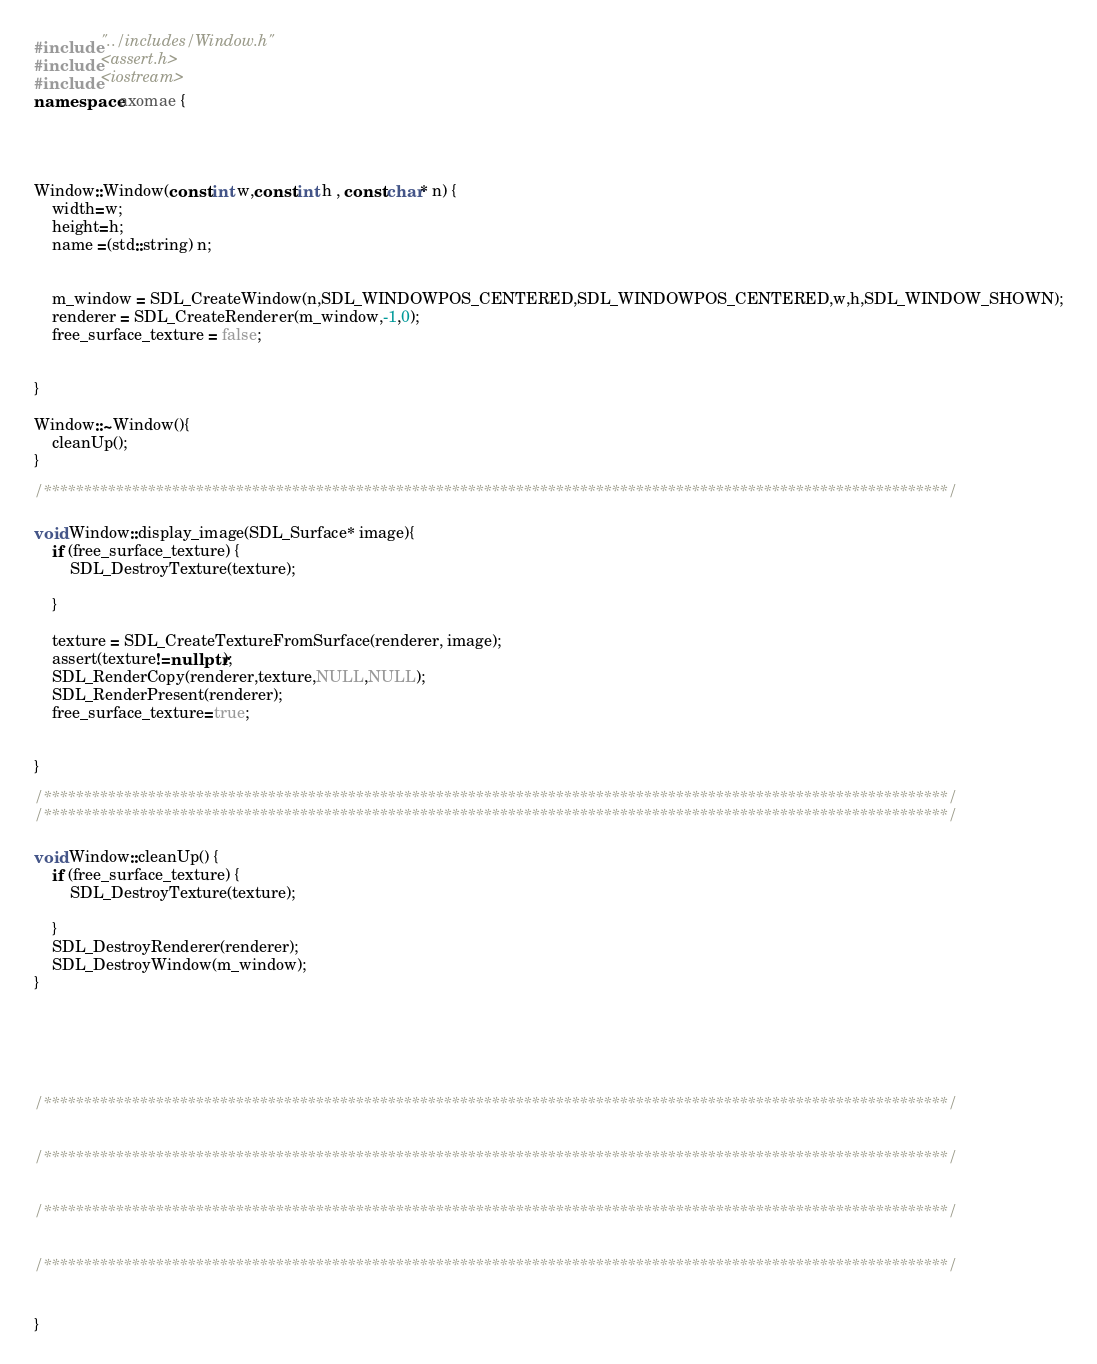Convert code to text. <code><loc_0><loc_0><loc_500><loc_500><_C++_>#include "../includes/Window.h"
#include <assert.h>
#include <iostream>
namespace axomae {




Window::Window(const int w,const int h , const char* n) {
	width=w; 
	height=h;
	name =(std::string) n;


	m_window = SDL_CreateWindow(n,SDL_WINDOWPOS_CENTERED,SDL_WINDOWPOS_CENTERED,w,h,SDL_WINDOW_SHOWN);
	renderer = SDL_CreateRenderer(m_window,-1,0);
	free_surface_texture = false;

	
}

Window::~Window(){
	cleanUp(); 
}

/*****************************************************************************************************************/

void Window::display_image(SDL_Surface* image){
	if (free_surface_texture) {
		SDL_DestroyTexture(texture); 
		
	}

	texture = SDL_CreateTextureFromSurface(renderer, image);
	assert(texture!=nullptr);
	SDL_RenderCopy(renderer,texture,NULL,NULL);
	SDL_RenderPresent(renderer);
	free_surface_texture=true;


}

/*****************************************************************************************************************/
/*****************************************************************************************************************/

void Window::cleanUp() {
	if (free_surface_texture) {
		SDL_DestroyTexture(texture);

	}
	SDL_DestroyRenderer(renderer);
	SDL_DestroyWindow(m_window);
}






/*****************************************************************************************************************/


/*****************************************************************************************************************/


/*****************************************************************************************************************/


/*****************************************************************************************************************/


}
</code> 